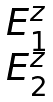<formula> <loc_0><loc_0><loc_500><loc_500>\begin{matrix} E _ { 1 } ^ { z } \\ E _ { 2 } ^ { z } \end{matrix}</formula> 